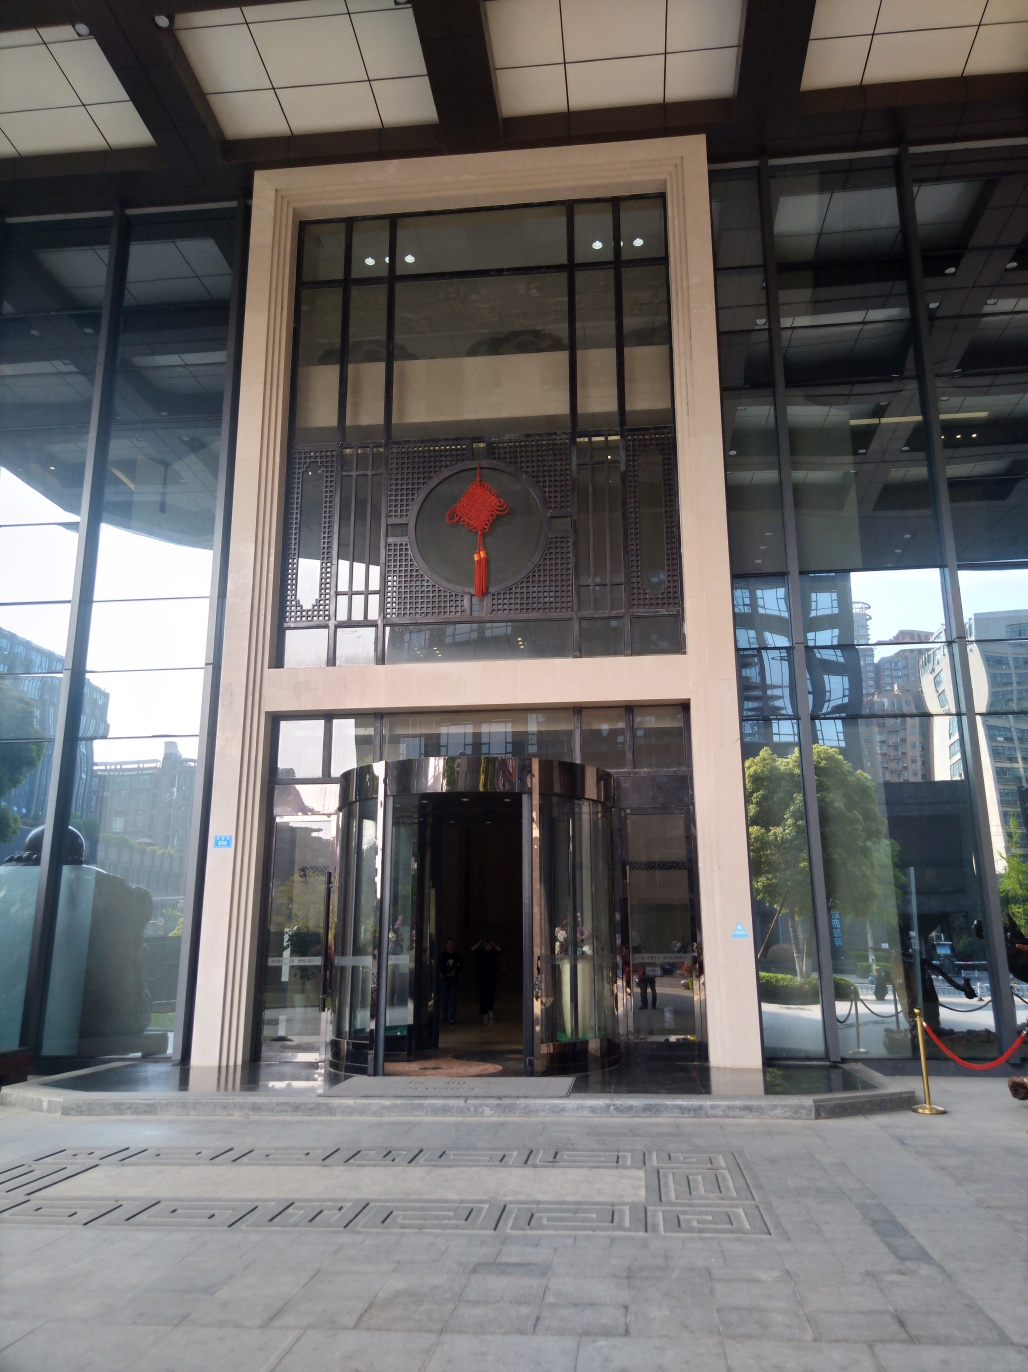Can you tell me more about the architectural style of this building? The building showcases a modern architectural style with expansive glass facades, which allow natural light to fill the interior spaces. It features clean lines and a minimalist aesthetic, complemented by decorative elements like the traditional circular motif above the entrance, adding a touch of cultural heritage. 